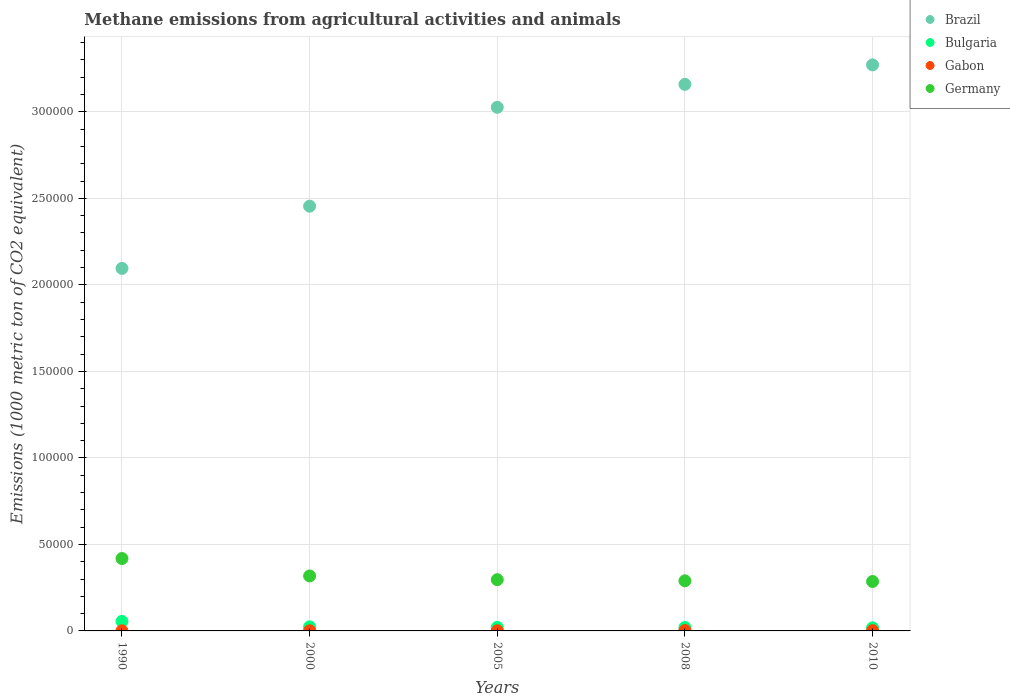What is the amount of methane emitted in Bulgaria in 2010?
Your response must be concise. 1771.6. Across all years, what is the maximum amount of methane emitted in Brazil?
Your answer should be very brief. 3.27e+05. Across all years, what is the minimum amount of methane emitted in Bulgaria?
Keep it short and to the point. 1771.6. In which year was the amount of methane emitted in Bulgaria minimum?
Ensure brevity in your answer.  2010. What is the total amount of methane emitted in Gabon in the graph?
Provide a succinct answer. 620.1. What is the difference between the amount of methane emitted in Brazil in 2008 and that in 2010?
Make the answer very short. -1.13e+04. What is the difference between the amount of methane emitted in Brazil in 2005 and the amount of methane emitted in Gabon in 1990?
Offer a very short reply. 3.03e+05. What is the average amount of methane emitted in Bulgaria per year?
Provide a succinct answer. 2725.36. In the year 2005, what is the difference between the amount of methane emitted in Gabon and amount of methane emitted in Germany?
Your response must be concise. -2.95e+04. In how many years, is the amount of methane emitted in Germany greater than 190000 1000 metric ton?
Your response must be concise. 0. What is the ratio of the amount of methane emitted in Brazil in 1990 to that in 2005?
Provide a short and direct response. 0.69. Is the difference between the amount of methane emitted in Gabon in 2000 and 2008 greater than the difference between the amount of methane emitted in Germany in 2000 and 2008?
Provide a short and direct response. No. What is the difference between the highest and the second highest amount of methane emitted in Germany?
Offer a very short reply. 1.01e+04. What is the difference between the highest and the lowest amount of methane emitted in Gabon?
Offer a terse response. 135.9. In how many years, is the amount of methane emitted in Gabon greater than the average amount of methane emitted in Gabon taken over all years?
Keep it short and to the point. 2. Is the sum of the amount of methane emitted in Bulgaria in 1990 and 2005 greater than the maximum amount of methane emitted in Brazil across all years?
Offer a terse response. No. Is it the case that in every year, the sum of the amount of methane emitted in Germany and amount of methane emitted in Bulgaria  is greater than the sum of amount of methane emitted in Gabon and amount of methane emitted in Brazil?
Your response must be concise. No. Is it the case that in every year, the sum of the amount of methane emitted in Bulgaria and amount of methane emitted in Brazil  is greater than the amount of methane emitted in Germany?
Offer a terse response. Yes. Is the amount of methane emitted in Brazil strictly less than the amount of methane emitted in Germany over the years?
Your response must be concise. No. Where does the legend appear in the graph?
Provide a succinct answer. Top right. What is the title of the graph?
Make the answer very short. Methane emissions from agricultural activities and animals. What is the label or title of the X-axis?
Your response must be concise. Years. What is the label or title of the Y-axis?
Make the answer very short. Emissions (1000 metric ton of CO2 equivalent). What is the Emissions (1000 metric ton of CO2 equivalent) in Brazil in 1990?
Your answer should be compact. 2.10e+05. What is the Emissions (1000 metric ton of CO2 equivalent) in Bulgaria in 1990?
Offer a terse response. 5498.3. What is the Emissions (1000 metric ton of CO2 equivalent) of Gabon in 1990?
Offer a terse response. 71.6. What is the Emissions (1000 metric ton of CO2 equivalent) of Germany in 1990?
Your answer should be very brief. 4.18e+04. What is the Emissions (1000 metric ton of CO2 equivalent) of Brazil in 2000?
Offer a terse response. 2.45e+05. What is the Emissions (1000 metric ton of CO2 equivalent) of Bulgaria in 2000?
Ensure brevity in your answer.  2359.5. What is the Emissions (1000 metric ton of CO2 equivalent) of Gabon in 2000?
Offer a terse response. 71.1. What is the Emissions (1000 metric ton of CO2 equivalent) in Germany in 2000?
Your response must be concise. 3.18e+04. What is the Emissions (1000 metric ton of CO2 equivalent) in Brazil in 2005?
Your answer should be compact. 3.03e+05. What is the Emissions (1000 metric ton of CO2 equivalent) in Bulgaria in 2005?
Your answer should be very brief. 2055.2. What is the Emissions (1000 metric ton of CO2 equivalent) in Gabon in 2005?
Provide a succinct answer. 96.3. What is the Emissions (1000 metric ton of CO2 equivalent) of Germany in 2005?
Your answer should be very brief. 2.96e+04. What is the Emissions (1000 metric ton of CO2 equivalent) of Brazil in 2008?
Your answer should be compact. 3.16e+05. What is the Emissions (1000 metric ton of CO2 equivalent) in Bulgaria in 2008?
Your answer should be very brief. 1942.2. What is the Emissions (1000 metric ton of CO2 equivalent) in Gabon in 2008?
Your answer should be compact. 207. What is the Emissions (1000 metric ton of CO2 equivalent) of Germany in 2008?
Give a very brief answer. 2.90e+04. What is the Emissions (1000 metric ton of CO2 equivalent) in Brazil in 2010?
Ensure brevity in your answer.  3.27e+05. What is the Emissions (1000 metric ton of CO2 equivalent) in Bulgaria in 2010?
Your response must be concise. 1771.6. What is the Emissions (1000 metric ton of CO2 equivalent) of Gabon in 2010?
Your answer should be compact. 174.1. What is the Emissions (1000 metric ton of CO2 equivalent) of Germany in 2010?
Offer a terse response. 2.86e+04. Across all years, what is the maximum Emissions (1000 metric ton of CO2 equivalent) in Brazil?
Provide a succinct answer. 3.27e+05. Across all years, what is the maximum Emissions (1000 metric ton of CO2 equivalent) of Bulgaria?
Your answer should be very brief. 5498.3. Across all years, what is the maximum Emissions (1000 metric ton of CO2 equivalent) in Gabon?
Ensure brevity in your answer.  207. Across all years, what is the maximum Emissions (1000 metric ton of CO2 equivalent) of Germany?
Offer a very short reply. 4.18e+04. Across all years, what is the minimum Emissions (1000 metric ton of CO2 equivalent) in Brazil?
Offer a very short reply. 2.10e+05. Across all years, what is the minimum Emissions (1000 metric ton of CO2 equivalent) in Bulgaria?
Make the answer very short. 1771.6. Across all years, what is the minimum Emissions (1000 metric ton of CO2 equivalent) in Gabon?
Provide a succinct answer. 71.1. Across all years, what is the minimum Emissions (1000 metric ton of CO2 equivalent) in Germany?
Your response must be concise. 2.86e+04. What is the total Emissions (1000 metric ton of CO2 equivalent) of Brazil in the graph?
Your answer should be compact. 1.40e+06. What is the total Emissions (1000 metric ton of CO2 equivalent) of Bulgaria in the graph?
Offer a terse response. 1.36e+04. What is the total Emissions (1000 metric ton of CO2 equivalent) of Gabon in the graph?
Your answer should be compact. 620.1. What is the total Emissions (1000 metric ton of CO2 equivalent) of Germany in the graph?
Provide a succinct answer. 1.61e+05. What is the difference between the Emissions (1000 metric ton of CO2 equivalent) in Brazil in 1990 and that in 2000?
Your answer should be compact. -3.60e+04. What is the difference between the Emissions (1000 metric ton of CO2 equivalent) in Bulgaria in 1990 and that in 2000?
Ensure brevity in your answer.  3138.8. What is the difference between the Emissions (1000 metric ton of CO2 equivalent) of Germany in 1990 and that in 2000?
Your answer should be very brief. 1.01e+04. What is the difference between the Emissions (1000 metric ton of CO2 equivalent) of Brazil in 1990 and that in 2005?
Give a very brief answer. -9.31e+04. What is the difference between the Emissions (1000 metric ton of CO2 equivalent) in Bulgaria in 1990 and that in 2005?
Your answer should be compact. 3443.1. What is the difference between the Emissions (1000 metric ton of CO2 equivalent) in Gabon in 1990 and that in 2005?
Offer a very short reply. -24.7. What is the difference between the Emissions (1000 metric ton of CO2 equivalent) of Germany in 1990 and that in 2005?
Offer a very short reply. 1.22e+04. What is the difference between the Emissions (1000 metric ton of CO2 equivalent) in Brazil in 1990 and that in 2008?
Ensure brevity in your answer.  -1.06e+05. What is the difference between the Emissions (1000 metric ton of CO2 equivalent) in Bulgaria in 1990 and that in 2008?
Make the answer very short. 3556.1. What is the difference between the Emissions (1000 metric ton of CO2 equivalent) in Gabon in 1990 and that in 2008?
Your answer should be compact. -135.4. What is the difference between the Emissions (1000 metric ton of CO2 equivalent) in Germany in 1990 and that in 2008?
Keep it short and to the point. 1.29e+04. What is the difference between the Emissions (1000 metric ton of CO2 equivalent) in Brazil in 1990 and that in 2010?
Your answer should be compact. -1.18e+05. What is the difference between the Emissions (1000 metric ton of CO2 equivalent) of Bulgaria in 1990 and that in 2010?
Your answer should be compact. 3726.7. What is the difference between the Emissions (1000 metric ton of CO2 equivalent) of Gabon in 1990 and that in 2010?
Keep it short and to the point. -102.5. What is the difference between the Emissions (1000 metric ton of CO2 equivalent) in Germany in 1990 and that in 2010?
Make the answer very short. 1.33e+04. What is the difference between the Emissions (1000 metric ton of CO2 equivalent) in Brazil in 2000 and that in 2005?
Keep it short and to the point. -5.71e+04. What is the difference between the Emissions (1000 metric ton of CO2 equivalent) of Bulgaria in 2000 and that in 2005?
Give a very brief answer. 304.3. What is the difference between the Emissions (1000 metric ton of CO2 equivalent) of Gabon in 2000 and that in 2005?
Provide a short and direct response. -25.2. What is the difference between the Emissions (1000 metric ton of CO2 equivalent) of Germany in 2000 and that in 2005?
Offer a terse response. 2155.4. What is the difference between the Emissions (1000 metric ton of CO2 equivalent) of Brazil in 2000 and that in 2008?
Give a very brief answer. -7.04e+04. What is the difference between the Emissions (1000 metric ton of CO2 equivalent) of Bulgaria in 2000 and that in 2008?
Keep it short and to the point. 417.3. What is the difference between the Emissions (1000 metric ton of CO2 equivalent) in Gabon in 2000 and that in 2008?
Make the answer very short. -135.9. What is the difference between the Emissions (1000 metric ton of CO2 equivalent) in Germany in 2000 and that in 2008?
Your answer should be compact. 2816.4. What is the difference between the Emissions (1000 metric ton of CO2 equivalent) of Brazil in 2000 and that in 2010?
Your answer should be very brief. -8.17e+04. What is the difference between the Emissions (1000 metric ton of CO2 equivalent) in Bulgaria in 2000 and that in 2010?
Your answer should be compact. 587.9. What is the difference between the Emissions (1000 metric ton of CO2 equivalent) of Gabon in 2000 and that in 2010?
Keep it short and to the point. -103. What is the difference between the Emissions (1000 metric ton of CO2 equivalent) in Germany in 2000 and that in 2010?
Give a very brief answer. 3209.1. What is the difference between the Emissions (1000 metric ton of CO2 equivalent) of Brazil in 2005 and that in 2008?
Make the answer very short. -1.33e+04. What is the difference between the Emissions (1000 metric ton of CO2 equivalent) in Bulgaria in 2005 and that in 2008?
Keep it short and to the point. 113. What is the difference between the Emissions (1000 metric ton of CO2 equivalent) of Gabon in 2005 and that in 2008?
Provide a succinct answer. -110.7. What is the difference between the Emissions (1000 metric ton of CO2 equivalent) in Germany in 2005 and that in 2008?
Ensure brevity in your answer.  661. What is the difference between the Emissions (1000 metric ton of CO2 equivalent) of Brazil in 2005 and that in 2010?
Give a very brief answer. -2.45e+04. What is the difference between the Emissions (1000 metric ton of CO2 equivalent) in Bulgaria in 2005 and that in 2010?
Provide a short and direct response. 283.6. What is the difference between the Emissions (1000 metric ton of CO2 equivalent) of Gabon in 2005 and that in 2010?
Offer a terse response. -77.8. What is the difference between the Emissions (1000 metric ton of CO2 equivalent) in Germany in 2005 and that in 2010?
Keep it short and to the point. 1053.7. What is the difference between the Emissions (1000 metric ton of CO2 equivalent) in Brazil in 2008 and that in 2010?
Provide a succinct answer. -1.13e+04. What is the difference between the Emissions (1000 metric ton of CO2 equivalent) in Bulgaria in 2008 and that in 2010?
Provide a succinct answer. 170.6. What is the difference between the Emissions (1000 metric ton of CO2 equivalent) in Gabon in 2008 and that in 2010?
Your answer should be compact. 32.9. What is the difference between the Emissions (1000 metric ton of CO2 equivalent) in Germany in 2008 and that in 2010?
Offer a very short reply. 392.7. What is the difference between the Emissions (1000 metric ton of CO2 equivalent) of Brazil in 1990 and the Emissions (1000 metric ton of CO2 equivalent) of Bulgaria in 2000?
Offer a very short reply. 2.07e+05. What is the difference between the Emissions (1000 metric ton of CO2 equivalent) in Brazil in 1990 and the Emissions (1000 metric ton of CO2 equivalent) in Gabon in 2000?
Keep it short and to the point. 2.09e+05. What is the difference between the Emissions (1000 metric ton of CO2 equivalent) of Brazil in 1990 and the Emissions (1000 metric ton of CO2 equivalent) of Germany in 2000?
Provide a short and direct response. 1.78e+05. What is the difference between the Emissions (1000 metric ton of CO2 equivalent) in Bulgaria in 1990 and the Emissions (1000 metric ton of CO2 equivalent) in Gabon in 2000?
Offer a terse response. 5427.2. What is the difference between the Emissions (1000 metric ton of CO2 equivalent) in Bulgaria in 1990 and the Emissions (1000 metric ton of CO2 equivalent) in Germany in 2000?
Keep it short and to the point. -2.63e+04. What is the difference between the Emissions (1000 metric ton of CO2 equivalent) in Gabon in 1990 and the Emissions (1000 metric ton of CO2 equivalent) in Germany in 2000?
Offer a very short reply. -3.17e+04. What is the difference between the Emissions (1000 metric ton of CO2 equivalent) in Brazil in 1990 and the Emissions (1000 metric ton of CO2 equivalent) in Bulgaria in 2005?
Provide a short and direct response. 2.07e+05. What is the difference between the Emissions (1000 metric ton of CO2 equivalent) in Brazil in 1990 and the Emissions (1000 metric ton of CO2 equivalent) in Gabon in 2005?
Offer a terse response. 2.09e+05. What is the difference between the Emissions (1000 metric ton of CO2 equivalent) in Brazil in 1990 and the Emissions (1000 metric ton of CO2 equivalent) in Germany in 2005?
Your answer should be very brief. 1.80e+05. What is the difference between the Emissions (1000 metric ton of CO2 equivalent) in Bulgaria in 1990 and the Emissions (1000 metric ton of CO2 equivalent) in Gabon in 2005?
Provide a short and direct response. 5402. What is the difference between the Emissions (1000 metric ton of CO2 equivalent) of Bulgaria in 1990 and the Emissions (1000 metric ton of CO2 equivalent) of Germany in 2005?
Your response must be concise. -2.41e+04. What is the difference between the Emissions (1000 metric ton of CO2 equivalent) of Gabon in 1990 and the Emissions (1000 metric ton of CO2 equivalent) of Germany in 2005?
Your answer should be very brief. -2.95e+04. What is the difference between the Emissions (1000 metric ton of CO2 equivalent) of Brazil in 1990 and the Emissions (1000 metric ton of CO2 equivalent) of Bulgaria in 2008?
Offer a terse response. 2.08e+05. What is the difference between the Emissions (1000 metric ton of CO2 equivalent) of Brazil in 1990 and the Emissions (1000 metric ton of CO2 equivalent) of Gabon in 2008?
Keep it short and to the point. 2.09e+05. What is the difference between the Emissions (1000 metric ton of CO2 equivalent) in Brazil in 1990 and the Emissions (1000 metric ton of CO2 equivalent) in Germany in 2008?
Offer a terse response. 1.81e+05. What is the difference between the Emissions (1000 metric ton of CO2 equivalent) of Bulgaria in 1990 and the Emissions (1000 metric ton of CO2 equivalent) of Gabon in 2008?
Ensure brevity in your answer.  5291.3. What is the difference between the Emissions (1000 metric ton of CO2 equivalent) in Bulgaria in 1990 and the Emissions (1000 metric ton of CO2 equivalent) in Germany in 2008?
Keep it short and to the point. -2.35e+04. What is the difference between the Emissions (1000 metric ton of CO2 equivalent) in Gabon in 1990 and the Emissions (1000 metric ton of CO2 equivalent) in Germany in 2008?
Keep it short and to the point. -2.89e+04. What is the difference between the Emissions (1000 metric ton of CO2 equivalent) of Brazil in 1990 and the Emissions (1000 metric ton of CO2 equivalent) of Bulgaria in 2010?
Ensure brevity in your answer.  2.08e+05. What is the difference between the Emissions (1000 metric ton of CO2 equivalent) of Brazil in 1990 and the Emissions (1000 metric ton of CO2 equivalent) of Gabon in 2010?
Ensure brevity in your answer.  2.09e+05. What is the difference between the Emissions (1000 metric ton of CO2 equivalent) of Brazil in 1990 and the Emissions (1000 metric ton of CO2 equivalent) of Germany in 2010?
Make the answer very short. 1.81e+05. What is the difference between the Emissions (1000 metric ton of CO2 equivalent) of Bulgaria in 1990 and the Emissions (1000 metric ton of CO2 equivalent) of Gabon in 2010?
Your answer should be very brief. 5324.2. What is the difference between the Emissions (1000 metric ton of CO2 equivalent) in Bulgaria in 1990 and the Emissions (1000 metric ton of CO2 equivalent) in Germany in 2010?
Provide a succinct answer. -2.31e+04. What is the difference between the Emissions (1000 metric ton of CO2 equivalent) in Gabon in 1990 and the Emissions (1000 metric ton of CO2 equivalent) in Germany in 2010?
Keep it short and to the point. -2.85e+04. What is the difference between the Emissions (1000 metric ton of CO2 equivalent) in Brazil in 2000 and the Emissions (1000 metric ton of CO2 equivalent) in Bulgaria in 2005?
Ensure brevity in your answer.  2.43e+05. What is the difference between the Emissions (1000 metric ton of CO2 equivalent) in Brazil in 2000 and the Emissions (1000 metric ton of CO2 equivalent) in Gabon in 2005?
Your answer should be compact. 2.45e+05. What is the difference between the Emissions (1000 metric ton of CO2 equivalent) of Brazil in 2000 and the Emissions (1000 metric ton of CO2 equivalent) of Germany in 2005?
Your answer should be very brief. 2.16e+05. What is the difference between the Emissions (1000 metric ton of CO2 equivalent) in Bulgaria in 2000 and the Emissions (1000 metric ton of CO2 equivalent) in Gabon in 2005?
Keep it short and to the point. 2263.2. What is the difference between the Emissions (1000 metric ton of CO2 equivalent) of Bulgaria in 2000 and the Emissions (1000 metric ton of CO2 equivalent) of Germany in 2005?
Make the answer very short. -2.73e+04. What is the difference between the Emissions (1000 metric ton of CO2 equivalent) of Gabon in 2000 and the Emissions (1000 metric ton of CO2 equivalent) of Germany in 2005?
Your answer should be compact. -2.95e+04. What is the difference between the Emissions (1000 metric ton of CO2 equivalent) of Brazil in 2000 and the Emissions (1000 metric ton of CO2 equivalent) of Bulgaria in 2008?
Provide a succinct answer. 2.44e+05. What is the difference between the Emissions (1000 metric ton of CO2 equivalent) of Brazil in 2000 and the Emissions (1000 metric ton of CO2 equivalent) of Gabon in 2008?
Provide a succinct answer. 2.45e+05. What is the difference between the Emissions (1000 metric ton of CO2 equivalent) of Brazil in 2000 and the Emissions (1000 metric ton of CO2 equivalent) of Germany in 2008?
Provide a short and direct response. 2.17e+05. What is the difference between the Emissions (1000 metric ton of CO2 equivalent) in Bulgaria in 2000 and the Emissions (1000 metric ton of CO2 equivalent) in Gabon in 2008?
Ensure brevity in your answer.  2152.5. What is the difference between the Emissions (1000 metric ton of CO2 equivalent) in Bulgaria in 2000 and the Emissions (1000 metric ton of CO2 equivalent) in Germany in 2008?
Make the answer very short. -2.66e+04. What is the difference between the Emissions (1000 metric ton of CO2 equivalent) of Gabon in 2000 and the Emissions (1000 metric ton of CO2 equivalent) of Germany in 2008?
Your response must be concise. -2.89e+04. What is the difference between the Emissions (1000 metric ton of CO2 equivalent) of Brazil in 2000 and the Emissions (1000 metric ton of CO2 equivalent) of Bulgaria in 2010?
Your answer should be compact. 2.44e+05. What is the difference between the Emissions (1000 metric ton of CO2 equivalent) in Brazil in 2000 and the Emissions (1000 metric ton of CO2 equivalent) in Gabon in 2010?
Your answer should be very brief. 2.45e+05. What is the difference between the Emissions (1000 metric ton of CO2 equivalent) in Brazil in 2000 and the Emissions (1000 metric ton of CO2 equivalent) in Germany in 2010?
Provide a succinct answer. 2.17e+05. What is the difference between the Emissions (1000 metric ton of CO2 equivalent) of Bulgaria in 2000 and the Emissions (1000 metric ton of CO2 equivalent) of Gabon in 2010?
Ensure brevity in your answer.  2185.4. What is the difference between the Emissions (1000 metric ton of CO2 equivalent) of Bulgaria in 2000 and the Emissions (1000 metric ton of CO2 equivalent) of Germany in 2010?
Your response must be concise. -2.62e+04. What is the difference between the Emissions (1000 metric ton of CO2 equivalent) of Gabon in 2000 and the Emissions (1000 metric ton of CO2 equivalent) of Germany in 2010?
Offer a very short reply. -2.85e+04. What is the difference between the Emissions (1000 metric ton of CO2 equivalent) of Brazil in 2005 and the Emissions (1000 metric ton of CO2 equivalent) of Bulgaria in 2008?
Offer a very short reply. 3.01e+05. What is the difference between the Emissions (1000 metric ton of CO2 equivalent) in Brazil in 2005 and the Emissions (1000 metric ton of CO2 equivalent) in Gabon in 2008?
Ensure brevity in your answer.  3.02e+05. What is the difference between the Emissions (1000 metric ton of CO2 equivalent) in Brazil in 2005 and the Emissions (1000 metric ton of CO2 equivalent) in Germany in 2008?
Provide a succinct answer. 2.74e+05. What is the difference between the Emissions (1000 metric ton of CO2 equivalent) in Bulgaria in 2005 and the Emissions (1000 metric ton of CO2 equivalent) in Gabon in 2008?
Offer a terse response. 1848.2. What is the difference between the Emissions (1000 metric ton of CO2 equivalent) in Bulgaria in 2005 and the Emissions (1000 metric ton of CO2 equivalent) in Germany in 2008?
Your answer should be compact. -2.69e+04. What is the difference between the Emissions (1000 metric ton of CO2 equivalent) of Gabon in 2005 and the Emissions (1000 metric ton of CO2 equivalent) of Germany in 2008?
Offer a terse response. -2.89e+04. What is the difference between the Emissions (1000 metric ton of CO2 equivalent) in Brazil in 2005 and the Emissions (1000 metric ton of CO2 equivalent) in Bulgaria in 2010?
Your answer should be compact. 3.01e+05. What is the difference between the Emissions (1000 metric ton of CO2 equivalent) of Brazil in 2005 and the Emissions (1000 metric ton of CO2 equivalent) of Gabon in 2010?
Make the answer very short. 3.02e+05. What is the difference between the Emissions (1000 metric ton of CO2 equivalent) in Brazil in 2005 and the Emissions (1000 metric ton of CO2 equivalent) in Germany in 2010?
Make the answer very short. 2.74e+05. What is the difference between the Emissions (1000 metric ton of CO2 equivalent) of Bulgaria in 2005 and the Emissions (1000 metric ton of CO2 equivalent) of Gabon in 2010?
Your response must be concise. 1881.1. What is the difference between the Emissions (1000 metric ton of CO2 equivalent) in Bulgaria in 2005 and the Emissions (1000 metric ton of CO2 equivalent) in Germany in 2010?
Offer a terse response. -2.65e+04. What is the difference between the Emissions (1000 metric ton of CO2 equivalent) in Gabon in 2005 and the Emissions (1000 metric ton of CO2 equivalent) in Germany in 2010?
Your answer should be compact. -2.85e+04. What is the difference between the Emissions (1000 metric ton of CO2 equivalent) of Brazil in 2008 and the Emissions (1000 metric ton of CO2 equivalent) of Bulgaria in 2010?
Ensure brevity in your answer.  3.14e+05. What is the difference between the Emissions (1000 metric ton of CO2 equivalent) in Brazil in 2008 and the Emissions (1000 metric ton of CO2 equivalent) in Gabon in 2010?
Ensure brevity in your answer.  3.16e+05. What is the difference between the Emissions (1000 metric ton of CO2 equivalent) of Brazil in 2008 and the Emissions (1000 metric ton of CO2 equivalent) of Germany in 2010?
Provide a succinct answer. 2.87e+05. What is the difference between the Emissions (1000 metric ton of CO2 equivalent) of Bulgaria in 2008 and the Emissions (1000 metric ton of CO2 equivalent) of Gabon in 2010?
Provide a succinct answer. 1768.1. What is the difference between the Emissions (1000 metric ton of CO2 equivalent) of Bulgaria in 2008 and the Emissions (1000 metric ton of CO2 equivalent) of Germany in 2010?
Ensure brevity in your answer.  -2.66e+04. What is the difference between the Emissions (1000 metric ton of CO2 equivalent) of Gabon in 2008 and the Emissions (1000 metric ton of CO2 equivalent) of Germany in 2010?
Keep it short and to the point. -2.84e+04. What is the average Emissions (1000 metric ton of CO2 equivalent) in Brazil per year?
Offer a terse response. 2.80e+05. What is the average Emissions (1000 metric ton of CO2 equivalent) of Bulgaria per year?
Provide a short and direct response. 2725.36. What is the average Emissions (1000 metric ton of CO2 equivalent) of Gabon per year?
Provide a short and direct response. 124.02. What is the average Emissions (1000 metric ton of CO2 equivalent) of Germany per year?
Provide a short and direct response. 3.21e+04. In the year 1990, what is the difference between the Emissions (1000 metric ton of CO2 equivalent) in Brazil and Emissions (1000 metric ton of CO2 equivalent) in Bulgaria?
Your answer should be compact. 2.04e+05. In the year 1990, what is the difference between the Emissions (1000 metric ton of CO2 equivalent) in Brazil and Emissions (1000 metric ton of CO2 equivalent) in Gabon?
Ensure brevity in your answer.  2.09e+05. In the year 1990, what is the difference between the Emissions (1000 metric ton of CO2 equivalent) of Brazil and Emissions (1000 metric ton of CO2 equivalent) of Germany?
Your response must be concise. 1.68e+05. In the year 1990, what is the difference between the Emissions (1000 metric ton of CO2 equivalent) in Bulgaria and Emissions (1000 metric ton of CO2 equivalent) in Gabon?
Ensure brevity in your answer.  5426.7. In the year 1990, what is the difference between the Emissions (1000 metric ton of CO2 equivalent) of Bulgaria and Emissions (1000 metric ton of CO2 equivalent) of Germany?
Provide a succinct answer. -3.63e+04. In the year 1990, what is the difference between the Emissions (1000 metric ton of CO2 equivalent) in Gabon and Emissions (1000 metric ton of CO2 equivalent) in Germany?
Your response must be concise. -4.18e+04. In the year 2000, what is the difference between the Emissions (1000 metric ton of CO2 equivalent) of Brazil and Emissions (1000 metric ton of CO2 equivalent) of Bulgaria?
Ensure brevity in your answer.  2.43e+05. In the year 2000, what is the difference between the Emissions (1000 metric ton of CO2 equivalent) of Brazil and Emissions (1000 metric ton of CO2 equivalent) of Gabon?
Provide a succinct answer. 2.45e+05. In the year 2000, what is the difference between the Emissions (1000 metric ton of CO2 equivalent) in Brazil and Emissions (1000 metric ton of CO2 equivalent) in Germany?
Offer a very short reply. 2.14e+05. In the year 2000, what is the difference between the Emissions (1000 metric ton of CO2 equivalent) of Bulgaria and Emissions (1000 metric ton of CO2 equivalent) of Gabon?
Give a very brief answer. 2288.4. In the year 2000, what is the difference between the Emissions (1000 metric ton of CO2 equivalent) in Bulgaria and Emissions (1000 metric ton of CO2 equivalent) in Germany?
Offer a terse response. -2.94e+04. In the year 2000, what is the difference between the Emissions (1000 metric ton of CO2 equivalent) in Gabon and Emissions (1000 metric ton of CO2 equivalent) in Germany?
Offer a terse response. -3.17e+04. In the year 2005, what is the difference between the Emissions (1000 metric ton of CO2 equivalent) of Brazil and Emissions (1000 metric ton of CO2 equivalent) of Bulgaria?
Keep it short and to the point. 3.01e+05. In the year 2005, what is the difference between the Emissions (1000 metric ton of CO2 equivalent) of Brazil and Emissions (1000 metric ton of CO2 equivalent) of Gabon?
Your answer should be very brief. 3.03e+05. In the year 2005, what is the difference between the Emissions (1000 metric ton of CO2 equivalent) in Brazil and Emissions (1000 metric ton of CO2 equivalent) in Germany?
Your response must be concise. 2.73e+05. In the year 2005, what is the difference between the Emissions (1000 metric ton of CO2 equivalent) of Bulgaria and Emissions (1000 metric ton of CO2 equivalent) of Gabon?
Provide a succinct answer. 1958.9. In the year 2005, what is the difference between the Emissions (1000 metric ton of CO2 equivalent) in Bulgaria and Emissions (1000 metric ton of CO2 equivalent) in Germany?
Your response must be concise. -2.76e+04. In the year 2005, what is the difference between the Emissions (1000 metric ton of CO2 equivalent) of Gabon and Emissions (1000 metric ton of CO2 equivalent) of Germany?
Make the answer very short. -2.95e+04. In the year 2008, what is the difference between the Emissions (1000 metric ton of CO2 equivalent) in Brazil and Emissions (1000 metric ton of CO2 equivalent) in Bulgaria?
Your answer should be very brief. 3.14e+05. In the year 2008, what is the difference between the Emissions (1000 metric ton of CO2 equivalent) of Brazil and Emissions (1000 metric ton of CO2 equivalent) of Gabon?
Your answer should be very brief. 3.16e+05. In the year 2008, what is the difference between the Emissions (1000 metric ton of CO2 equivalent) of Brazil and Emissions (1000 metric ton of CO2 equivalent) of Germany?
Your answer should be very brief. 2.87e+05. In the year 2008, what is the difference between the Emissions (1000 metric ton of CO2 equivalent) of Bulgaria and Emissions (1000 metric ton of CO2 equivalent) of Gabon?
Provide a succinct answer. 1735.2. In the year 2008, what is the difference between the Emissions (1000 metric ton of CO2 equivalent) of Bulgaria and Emissions (1000 metric ton of CO2 equivalent) of Germany?
Your response must be concise. -2.70e+04. In the year 2008, what is the difference between the Emissions (1000 metric ton of CO2 equivalent) in Gabon and Emissions (1000 metric ton of CO2 equivalent) in Germany?
Ensure brevity in your answer.  -2.88e+04. In the year 2010, what is the difference between the Emissions (1000 metric ton of CO2 equivalent) of Brazil and Emissions (1000 metric ton of CO2 equivalent) of Bulgaria?
Make the answer very short. 3.25e+05. In the year 2010, what is the difference between the Emissions (1000 metric ton of CO2 equivalent) in Brazil and Emissions (1000 metric ton of CO2 equivalent) in Gabon?
Ensure brevity in your answer.  3.27e+05. In the year 2010, what is the difference between the Emissions (1000 metric ton of CO2 equivalent) of Brazil and Emissions (1000 metric ton of CO2 equivalent) of Germany?
Your response must be concise. 2.99e+05. In the year 2010, what is the difference between the Emissions (1000 metric ton of CO2 equivalent) of Bulgaria and Emissions (1000 metric ton of CO2 equivalent) of Gabon?
Offer a terse response. 1597.5. In the year 2010, what is the difference between the Emissions (1000 metric ton of CO2 equivalent) of Bulgaria and Emissions (1000 metric ton of CO2 equivalent) of Germany?
Provide a short and direct response. -2.68e+04. In the year 2010, what is the difference between the Emissions (1000 metric ton of CO2 equivalent) in Gabon and Emissions (1000 metric ton of CO2 equivalent) in Germany?
Your answer should be very brief. -2.84e+04. What is the ratio of the Emissions (1000 metric ton of CO2 equivalent) of Brazil in 1990 to that in 2000?
Ensure brevity in your answer.  0.85. What is the ratio of the Emissions (1000 metric ton of CO2 equivalent) of Bulgaria in 1990 to that in 2000?
Offer a terse response. 2.33. What is the ratio of the Emissions (1000 metric ton of CO2 equivalent) in Gabon in 1990 to that in 2000?
Ensure brevity in your answer.  1.01. What is the ratio of the Emissions (1000 metric ton of CO2 equivalent) in Germany in 1990 to that in 2000?
Offer a terse response. 1.32. What is the ratio of the Emissions (1000 metric ton of CO2 equivalent) in Brazil in 1990 to that in 2005?
Offer a very short reply. 0.69. What is the ratio of the Emissions (1000 metric ton of CO2 equivalent) of Bulgaria in 1990 to that in 2005?
Ensure brevity in your answer.  2.68. What is the ratio of the Emissions (1000 metric ton of CO2 equivalent) in Gabon in 1990 to that in 2005?
Provide a short and direct response. 0.74. What is the ratio of the Emissions (1000 metric ton of CO2 equivalent) of Germany in 1990 to that in 2005?
Keep it short and to the point. 1.41. What is the ratio of the Emissions (1000 metric ton of CO2 equivalent) in Brazil in 1990 to that in 2008?
Ensure brevity in your answer.  0.66. What is the ratio of the Emissions (1000 metric ton of CO2 equivalent) of Bulgaria in 1990 to that in 2008?
Ensure brevity in your answer.  2.83. What is the ratio of the Emissions (1000 metric ton of CO2 equivalent) of Gabon in 1990 to that in 2008?
Make the answer very short. 0.35. What is the ratio of the Emissions (1000 metric ton of CO2 equivalent) in Germany in 1990 to that in 2008?
Keep it short and to the point. 1.44. What is the ratio of the Emissions (1000 metric ton of CO2 equivalent) in Brazil in 1990 to that in 2010?
Make the answer very short. 0.64. What is the ratio of the Emissions (1000 metric ton of CO2 equivalent) in Bulgaria in 1990 to that in 2010?
Your response must be concise. 3.1. What is the ratio of the Emissions (1000 metric ton of CO2 equivalent) of Gabon in 1990 to that in 2010?
Provide a short and direct response. 0.41. What is the ratio of the Emissions (1000 metric ton of CO2 equivalent) of Germany in 1990 to that in 2010?
Your answer should be very brief. 1.46. What is the ratio of the Emissions (1000 metric ton of CO2 equivalent) of Brazil in 2000 to that in 2005?
Ensure brevity in your answer.  0.81. What is the ratio of the Emissions (1000 metric ton of CO2 equivalent) of Bulgaria in 2000 to that in 2005?
Provide a short and direct response. 1.15. What is the ratio of the Emissions (1000 metric ton of CO2 equivalent) in Gabon in 2000 to that in 2005?
Give a very brief answer. 0.74. What is the ratio of the Emissions (1000 metric ton of CO2 equivalent) of Germany in 2000 to that in 2005?
Your answer should be compact. 1.07. What is the ratio of the Emissions (1000 metric ton of CO2 equivalent) of Brazil in 2000 to that in 2008?
Ensure brevity in your answer.  0.78. What is the ratio of the Emissions (1000 metric ton of CO2 equivalent) of Bulgaria in 2000 to that in 2008?
Your answer should be compact. 1.21. What is the ratio of the Emissions (1000 metric ton of CO2 equivalent) of Gabon in 2000 to that in 2008?
Provide a succinct answer. 0.34. What is the ratio of the Emissions (1000 metric ton of CO2 equivalent) in Germany in 2000 to that in 2008?
Keep it short and to the point. 1.1. What is the ratio of the Emissions (1000 metric ton of CO2 equivalent) of Brazil in 2000 to that in 2010?
Offer a very short reply. 0.75. What is the ratio of the Emissions (1000 metric ton of CO2 equivalent) in Bulgaria in 2000 to that in 2010?
Ensure brevity in your answer.  1.33. What is the ratio of the Emissions (1000 metric ton of CO2 equivalent) of Gabon in 2000 to that in 2010?
Give a very brief answer. 0.41. What is the ratio of the Emissions (1000 metric ton of CO2 equivalent) in Germany in 2000 to that in 2010?
Provide a short and direct response. 1.11. What is the ratio of the Emissions (1000 metric ton of CO2 equivalent) of Brazil in 2005 to that in 2008?
Your answer should be very brief. 0.96. What is the ratio of the Emissions (1000 metric ton of CO2 equivalent) in Bulgaria in 2005 to that in 2008?
Your answer should be compact. 1.06. What is the ratio of the Emissions (1000 metric ton of CO2 equivalent) of Gabon in 2005 to that in 2008?
Your response must be concise. 0.47. What is the ratio of the Emissions (1000 metric ton of CO2 equivalent) in Germany in 2005 to that in 2008?
Your response must be concise. 1.02. What is the ratio of the Emissions (1000 metric ton of CO2 equivalent) of Brazil in 2005 to that in 2010?
Your answer should be compact. 0.93. What is the ratio of the Emissions (1000 metric ton of CO2 equivalent) in Bulgaria in 2005 to that in 2010?
Provide a succinct answer. 1.16. What is the ratio of the Emissions (1000 metric ton of CO2 equivalent) in Gabon in 2005 to that in 2010?
Offer a very short reply. 0.55. What is the ratio of the Emissions (1000 metric ton of CO2 equivalent) of Germany in 2005 to that in 2010?
Provide a succinct answer. 1.04. What is the ratio of the Emissions (1000 metric ton of CO2 equivalent) of Brazil in 2008 to that in 2010?
Your response must be concise. 0.97. What is the ratio of the Emissions (1000 metric ton of CO2 equivalent) of Bulgaria in 2008 to that in 2010?
Make the answer very short. 1.1. What is the ratio of the Emissions (1000 metric ton of CO2 equivalent) in Gabon in 2008 to that in 2010?
Give a very brief answer. 1.19. What is the ratio of the Emissions (1000 metric ton of CO2 equivalent) in Germany in 2008 to that in 2010?
Ensure brevity in your answer.  1.01. What is the difference between the highest and the second highest Emissions (1000 metric ton of CO2 equivalent) in Brazil?
Ensure brevity in your answer.  1.13e+04. What is the difference between the highest and the second highest Emissions (1000 metric ton of CO2 equivalent) in Bulgaria?
Offer a very short reply. 3138.8. What is the difference between the highest and the second highest Emissions (1000 metric ton of CO2 equivalent) of Gabon?
Your response must be concise. 32.9. What is the difference between the highest and the second highest Emissions (1000 metric ton of CO2 equivalent) of Germany?
Provide a short and direct response. 1.01e+04. What is the difference between the highest and the lowest Emissions (1000 metric ton of CO2 equivalent) of Brazil?
Make the answer very short. 1.18e+05. What is the difference between the highest and the lowest Emissions (1000 metric ton of CO2 equivalent) of Bulgaria?
Offer a terse response. 3726.7. What is the difference between the highest and the lowest Emissions (1000 metric ton of CO2 equivalent) in Gabon?
Give a very brief answer. 135.9. What is the difference between the highest and the lowest Emissions (1000 metric ton of CO2 equivalent) of Germany?
Give a very brief answer. 1.33e+04. 